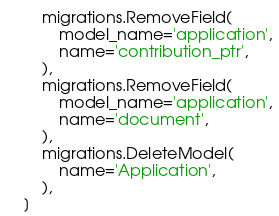Convert code to text. <code><loc_0><loc_0><loc_500><loc_500><_Python_>        migrations.RemoveField(
            model_name='application',
            name='contribution_ptr',
        ),
        migrations.RemoveField(
            model_name='application',
            name='document',
        ),
        migrations.DeleteModel(
            name='Application',
        ),
    ]
</code> 